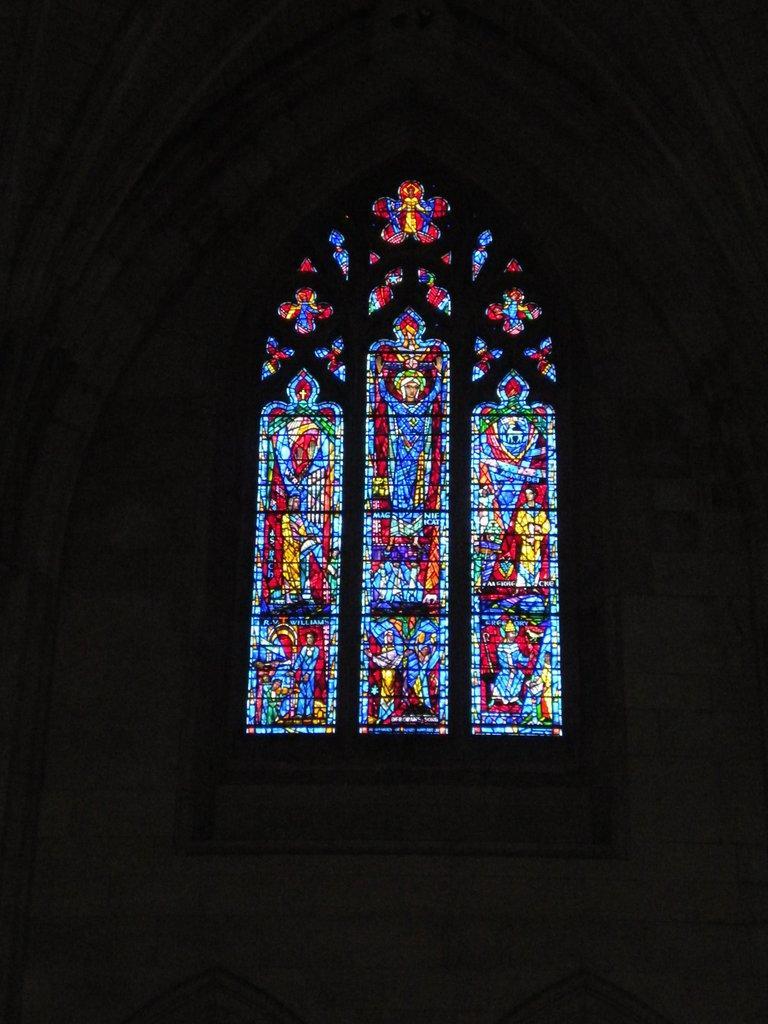How would you summarize this image in a sentence or two? In this picture we can see the glass window with colorful design. 